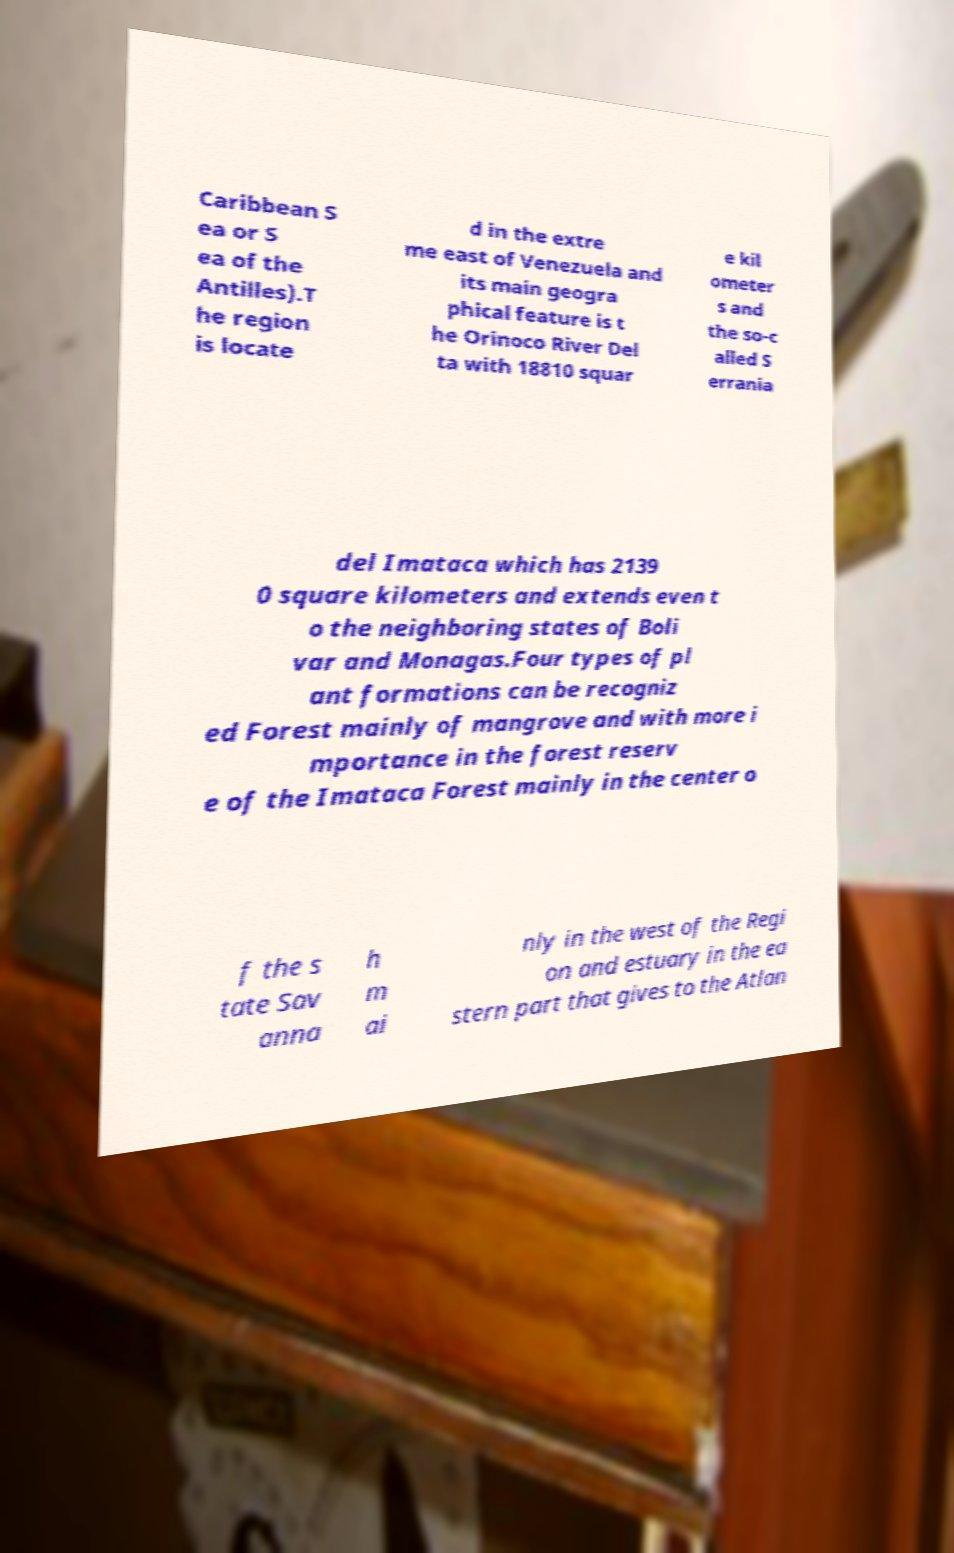For documentation purposes, I need the text within this image transcribed. Could you provide that? Caribbean S ea or S ea of the Antilles).T he region is locate d in the extre me east of Venezuela and its main geogra phical feature is t he Orinoco River Del ta with 18810 squar e kil ometer s and the so-c alled S errania del Imataca which has 2139 0 square kilometers and extends even t o the neighboring states of Boli var and Monagas.Four types of pl ant formations can be recogniz ed Forest mainly of mangrove and with more i mportance in the forest reserv e of the Imataca Forest mainly in the center o f the s tate Sav anna h m ai nly in the west of the Regi on and estuary in the ea stern part that gives to the Atlan 